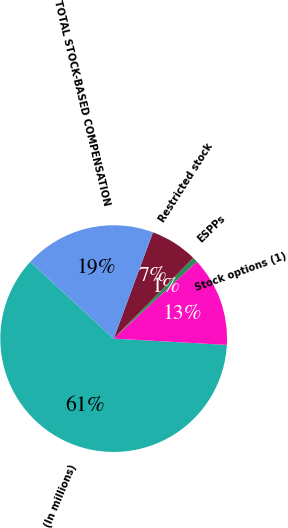Convert chart to OTSL. <chart><loc_0><loc_0><loc_500><loc_500><pie_chart><fcel>(In millions)<fcel>Stock options (1)<fcel>ESPPs<fcel>Restricted stock<fcel>TOTAL STOCK-BASED COMPENSATION<nl><fcel>60.96%<fcel>12.77%<fcel>0.73%<fcel>6.75%<fcel>18.8%<nl></chart> 